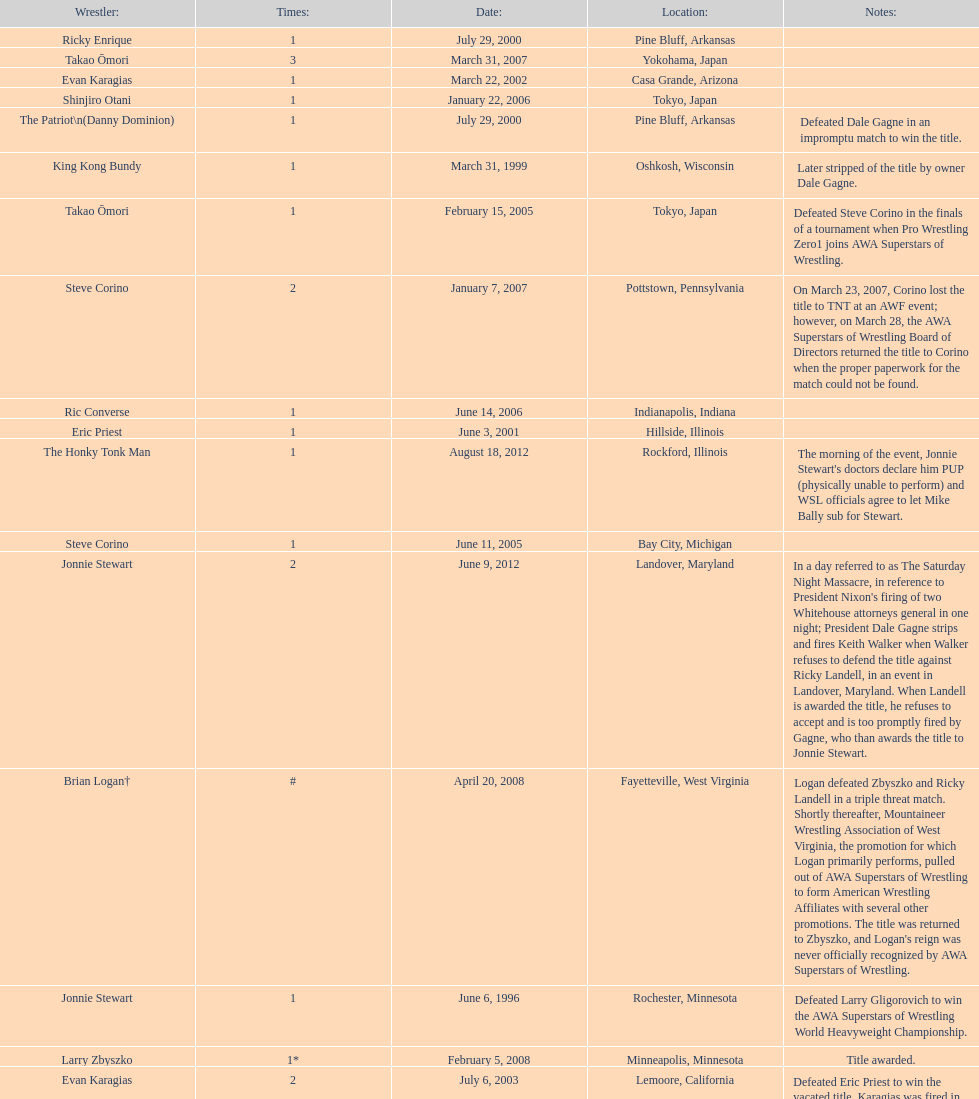Can you parse all the data within this table? {'header': ['Wrestler:', 'Times:', 'Date:', 'Location:', 'Notes:'], 'rows': [['Ricky Enrique', '1', 'July 29, 2000', 'Pine Bluff, Arkansas', ''], ['Takao Ōmori', '3', 'March 31, 2007', 'Yokohama, Japan', ''], ['Evan Karagias', '1', 'March 22, 2002', 'Casa Grande, Arizona', ''], ['Shinjiro Otani', '1', 'January 22, 2006', 'Tokyo, Japan', ''], ['The Patriot\\n(Danny Dominion)', '1', 'July 29, 2000', 'Pine Bluff, Arkansas', 'Defeated Dale Gagne in an impromptu match to win the title.'], ['King Kong Bundy', '1', 'March 31, 1999', 'Oshkosh, Wisconsin', 'Later stripped of the title by owner Dale Gagne.'], ['Takao Ōmori', '1', 'February 15, 2005', 'Tokyo, Japan', 'Defeated Steve Corino in the finals of a tournament when Pro Wrestling Zero1 joins AWA Superstars of Wrestling.'], ['Steve Corino', '2', 'January 7, 2007', 'Pottstown, Pennsylvania', 'On March 23, 2007, Corino lost the title to TNT at an AWF event; however, on March 28, the AWA Superstars of Wrestling Board of Directors returned the title to Corino when the proper paperwork for the match could not be found.'], ['Ric Converse', '1', 'June 14, 2006', 'Indianapolis, Indiana', ''], ['Eric Priest', '1', 'June 3, 2001', 'Hillside, Illinois', ''], ['The Honky Tonk Man', '1', 'August 18, 2012', 'Rockford, Illinois', "The morning of the event, Jonnie Stewart's doctors declare him PUP (physically unable to perform) and WSL officials agree to let Mike Bally sub for Stewart."], ['Steve Corino', '1', 'June 11, 2005', 'Bay City, Michigan', ''], ['Jonnie Stewart', '2', 'June 9, 2012', 'Landover, Maryland', "In a day referred to as The Saturday Night Massacre, in reference to President Nixon's firing of two Whitehouse attorneys general in one night; President Dale Gagne strips and fires Keith Walker when Walker refuses to defend the title against Ricky Landell, in an event in Landover, Maryland. When Landell is awarded the title, he refuses to accept and is too promptly fired by Gagne, who than awards the title to Jonnie Stewart."], ['Brian Logan†', '#', 'April 20, 2008', 'Fayetteville, West Virginia', "Logan defeated Zbyszko and Ricky Landell in a triple threat match. Shortly thereafter, Mountaineer Wrestling Association of West Virginia, the promotion for which Logan primarily performs, pulled out of AWA Superstars of Wrestling to form American Wrestling Affiliates with several other promotions. The title was returned to Zbyszko, and Logan's reign was never officially recognized by AWA Superstars of Wrestling."], ['Jonnie Stewart', '1', 'June 6, 1996', 'Rochester, Minnesota', 'Defeated Larry Gligorovich to win the AWA Superstars of Wrestling World Heavyweight Championship.'], ['Larry Zbyszko', '1*', 'February 5, 2008', 'Minneapolis, Minnesota', 'Title awarded.'], ['Evan Karagias', '2', 'July 6, 2003', 'Lemoore, California', 'Defeated Eric Priest to win the vacated title. Karagias was fired in January 2005 by Dale Gagne for misconduct and refusal of defending the title as scheduled.'], ['Ricky Landell', '1', 'October 11, 2008', 'Indianapolis, Indiana', 'Title becomes known as the WSL World Heavyweight Championship when the promotion is forced to rename.'], ['Takao Ōmori', '2', 'April 1, 2006', 'Tokyo, Japan', ''], ['Larry Zbyszko', '1*', '', '', 'Title returned to Zbyszko.'], ['Masato Tanaka', '1', 'October 26, 2007', 'Tokyo, Japan', ''], ['Keith Walker', '1', 'February 21, 2009', 'Michigan City, Indiana', ''], ['Horshu', '1', 'October 12, 2002', 'Mercedes, Texas', 'Stripped of the title due to missing mandatory title defenses.']]} When did steve corino win his first wsl title? June 11, 2005. 